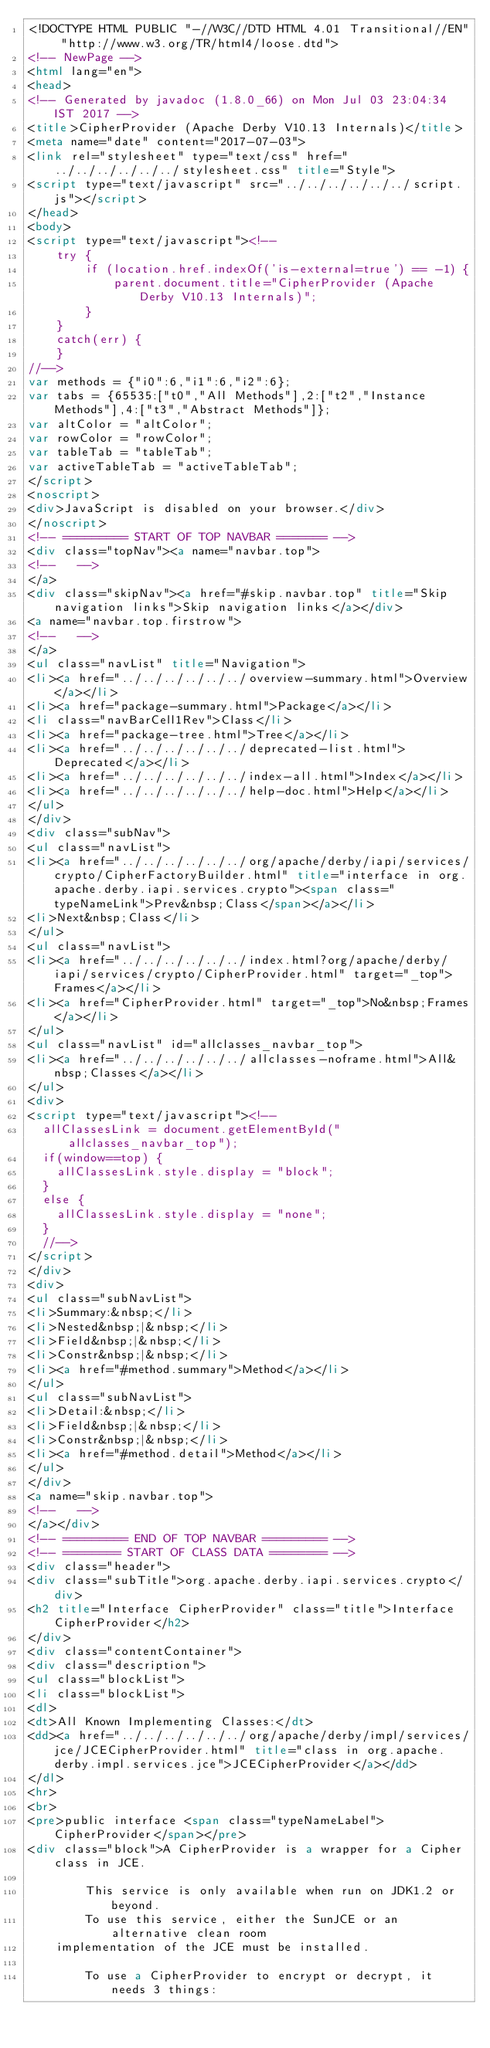<code> <loc_0><loc_0><loc_500><loc_500><_HTML_><!DOCTYPE HTML PUBLIC "-//W3C//DTD HTML 4.01 Transitional//EN" "http://www.w3.org/TR/html4/loose.dtd">
<!-- NewPage -->
<html lang="en">
<head>
<!-- Generated by javadoc (1.8.0_66) on Mon Jul 03 23:04:34 IST 2017 -->
<title>CipherProvider (Apache Derby V10.13 Internals)</title>
<meta name="date" content="2017-07-03">
<link rel="stylesheet" type="text/css" href="../../../../../../stylesheet.css" title="Style">
<script type="text/javascript" src="../../../../../../script.js"></script>
</head>
<body>
<script type="text/javascript"><!--
    try {
        if (location.href.indexOf('is-external=true') == -1) {
            parent.document.title="CipherProvider (Apache Derby V10.13 Internals)";
        }
    }
    catch(err) {
    }
//-->
var methods = {"i0":6,"i1":6,"i2":6};
var tabs = {65535:["t0","All Methods"],2:["t2","Instance Methods"],4:["t3","Abstract Methods"]};
var altColor = "altColor";
var rowColor = "rowColor";
var tableTab = "tableTab";
var activeTableTab = "activeTableTab";
</script>
<noscript>
<div>JavaScript is disabled on your browser.</div>
</noscript>
<!-- ========= START OF TOP NAVBAR ======= -->
<div class="topNav"><a name="navbar.top">
<!--   -->
</a>
<div class="skipNav"><a href="#skip.navbar.top" title="Skip navigation links">Skip navigation links</a></div>
<a name="navbar.top.firstrow">
<!--   -->
</a>
<ul class="navList" title="Navigation">
<li><a href="../../../../../../overview-summary.html">Overview</a></li>
<li><a href="package-summary.html">Package</a></li>
<li class="navBarCell1Rev">Class</li>
<li><a href="package-tree.html">Tree</a></li>
<li><a href="../../../../../../deprecated-list.html">Deprecated</a></li>
<li><a href="../../../../../../index-all.html">Index</a></li>
<li><a href="../../../../../../help-doc.html">Help</a></li>
</ul>
</div>
<div class="subNav">
<ul class="navList">
<li><a href="../../../../../../org/apache/derby/iapi/services/crypto/CipherFactoryBuilder.html" title="interface in org.apache.derby.iapi.services.crypto"><span class="typeNameLink">Prev&nbsp;Class</span></a></li>
<li>Next&nbsp;Class</li>
</ul>
<ul class="navList">
<li><a href="../../../../../../index.html?org/apache/derby/iapi/services/crypto/CipherProvider.html" target="_top">Frames</a></li>
<li><a href="CipherProvider.html" target="_top">No&nbsp;Frames</a></li>
</ul>
<ul class="navList" id="allclasses_navbar_top">
<li><a href="../../../../../../allclasses-noframe.html">All&nbsp;Classes</a></li>
</ul>
<div>
<script type="text/javascript"><!--
  allClassesLink = document.getElementById("allclasses_navbar_top");
  if(window==top) {
    allClassesLink.style.display = "block";
  }
  else {
    allClassesLink.style.display = "none";
  }
  //-->
</script>
</div>
<div>
<ul class="subNavList">
<li>Summary:&nbsp;</li>
<li>Nested&nbsp;|&nbsp;</li>
<li>Field&nbsp;|&nbsp;</li>
<li>Constr&nbsp;|&nbsp;</li>
<li><a href="#method.summary">Method</a></li>
</ul>
<ul class="subNavList">
<li>Detail:&nbsp;</li>
<li>Field&nbsp;|&nbsp;</li>
<li>Constr&nbsp;|&nbsp;</li>
<li><a href="#method.detail">Method</a></li>
</ul>
</div>
<a name="skip.navbar.top">
<!--   -->
</a></div>
<!-- ========= END OF TOP NAVBAR ========= -->
<!-- ======== START OF CLASS DATA ======== -->
<div class="header">
<div class="subTitle">org.apache.derby.iapi.services.crypto</div>
<h2 title="Interface CipherProvider" class="title">Interface CipherProvider</h2>
</div>
<div class="contentContainer">
<div class="description">
<ul class="blockList">
<li class="blockList">
<dl>
<dt>All Known Implementing Classes:</dt>
<dd><a href="../../../../../../org/apache/derby/impl/services/jce/JCECipherProvider.html" title="class in org.apache.derby.impl.services.jce">JCECipherProvider</a></dd>
</dl>
<hr>
<br>
<pre>public interface <span class="typeNameLabel">CipherProvider</span></pre>
<div class="block">A CipherProvider is a wrapper for a Cipher class in JCE.

        This service is only available when run on JDK1.2 or beyond.
        To use this service, either the SunJCE or an alternative clean room
    implementation of the JCE must be installed.

        To use a CipherProvider to encrypt or decrypt, it needs 3 things:</code> 